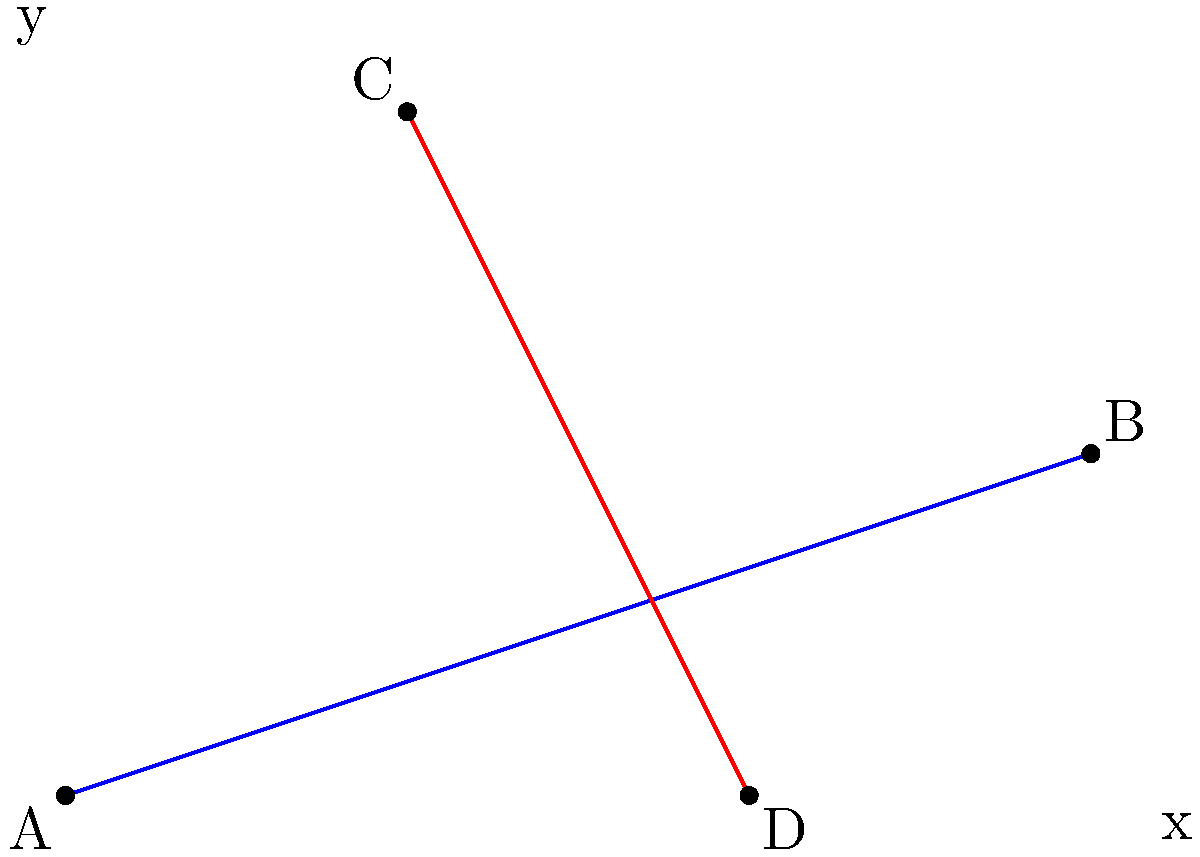As an entrepreneur who has experience with web applications, you understand the importance of geometry in UI design. Consider two intersecting lines in a coordinate plane: line AB (blue) passing through points A(0,0) and B(6,2), and line CD (red) passing through points C(2,4) and D(4,0). Calculate the acute angle between these two lines. To find the angle between two intersecting lines, we can use the following steps:

1. Calculate the slopes of both lines:
   
   Slope of AB: $m_1 = \frac{y_2 - y_1}{x_2 - x_1} = \frac{2 - 0}{6 - 0} = \frac{1}{3}$
   
   Slope of CD: $m_2 = \frac{y_2 - y_1}{x_2 - x_1} = \frac{0 - 4}{4 - 2} = -2$

2. Use the formula for the angle between two lines:
   
   $\tan \theta = |\frac{m_2 - m_1}{1 + m_1m_2}|$

3. Substitute the slopes into the formula:
   
   $\tan \theta = |\frac{-2 - \frac{1}{3}}{1 + (-2)(\frac{1}{3})}| = |\frac{-\frac{7}{3}}{\frac{1}{3}}| = 7$

4. Calculate the inverse tangent (arctangent) to find the angle:
   
   $\theta = \arctan(7)$

5. Convert the result to degrees:
   
   $\theta \approx 81.87°$

Therefore, the acute angle between the two lines is approximately 81.87°.
Answer: $81.87°$ 